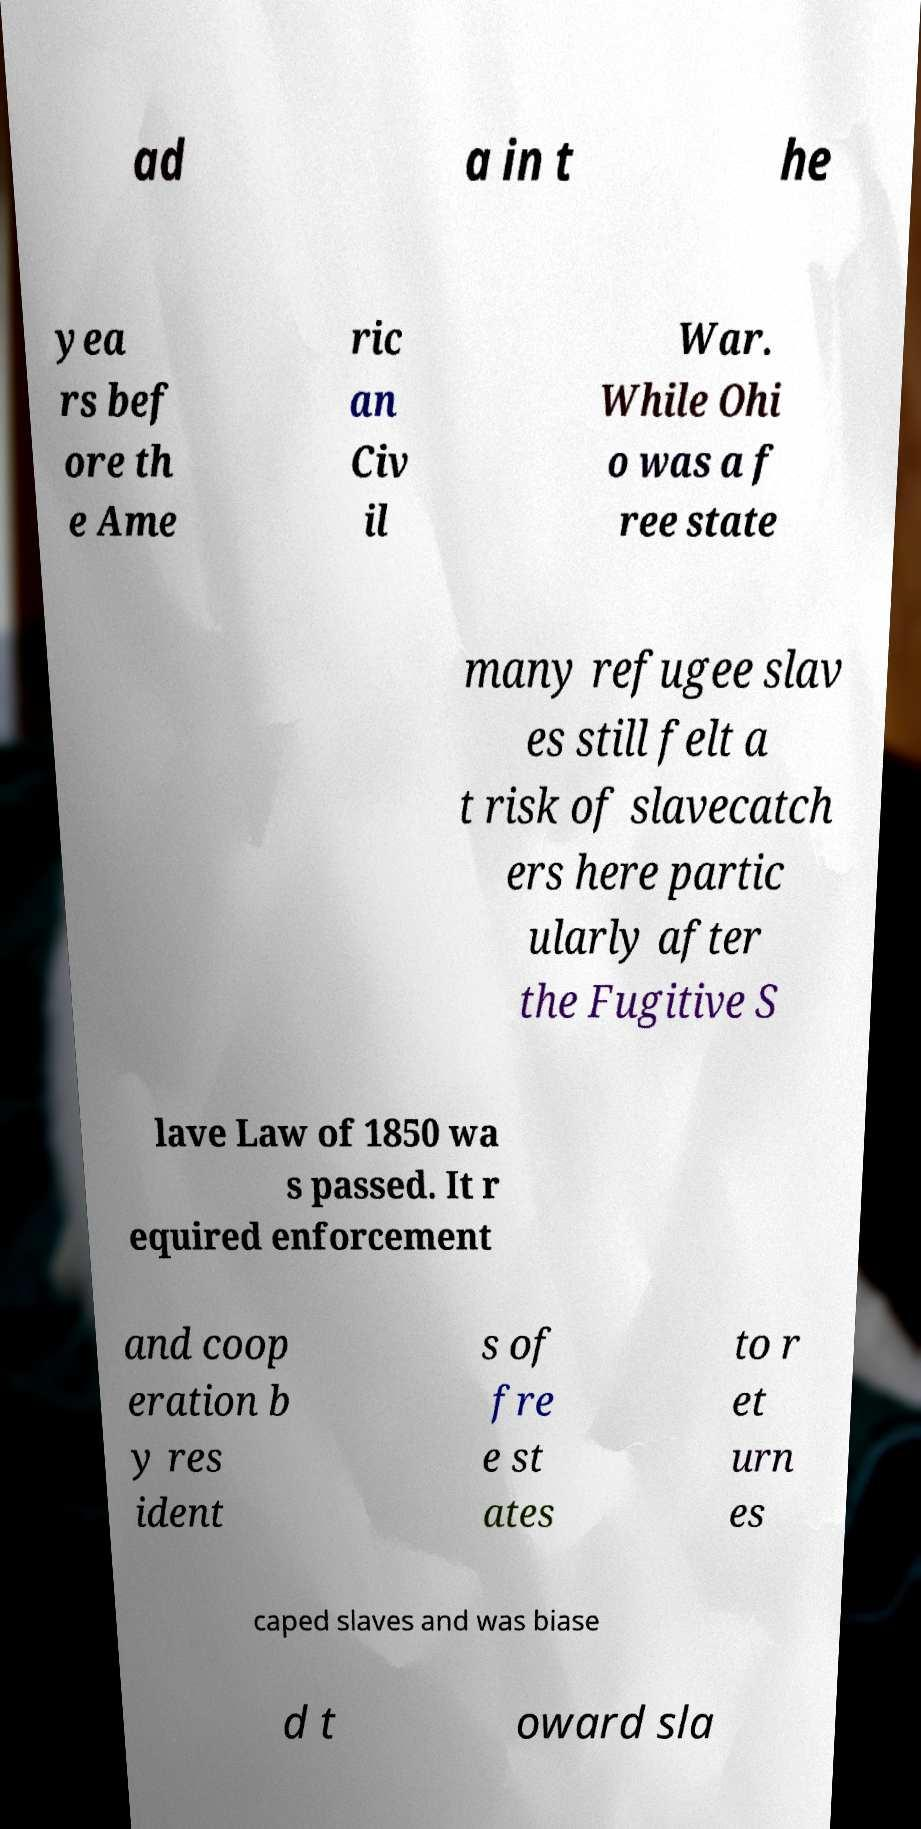Please identify and transcribe the text found in this image. ad a in t he yea rs bef ore th e Ame ric an Civ il War. While Ohi o was a f ree state many refugee slav es still felt a t risk of slavecatch ers here partic ularly after the Fugitive S lave Law of 1850 wa s passed. It r equired enforcement and coop eration b y res ident s of fre e st ates to r et urn es caped slaves and was biase d t oward sla 